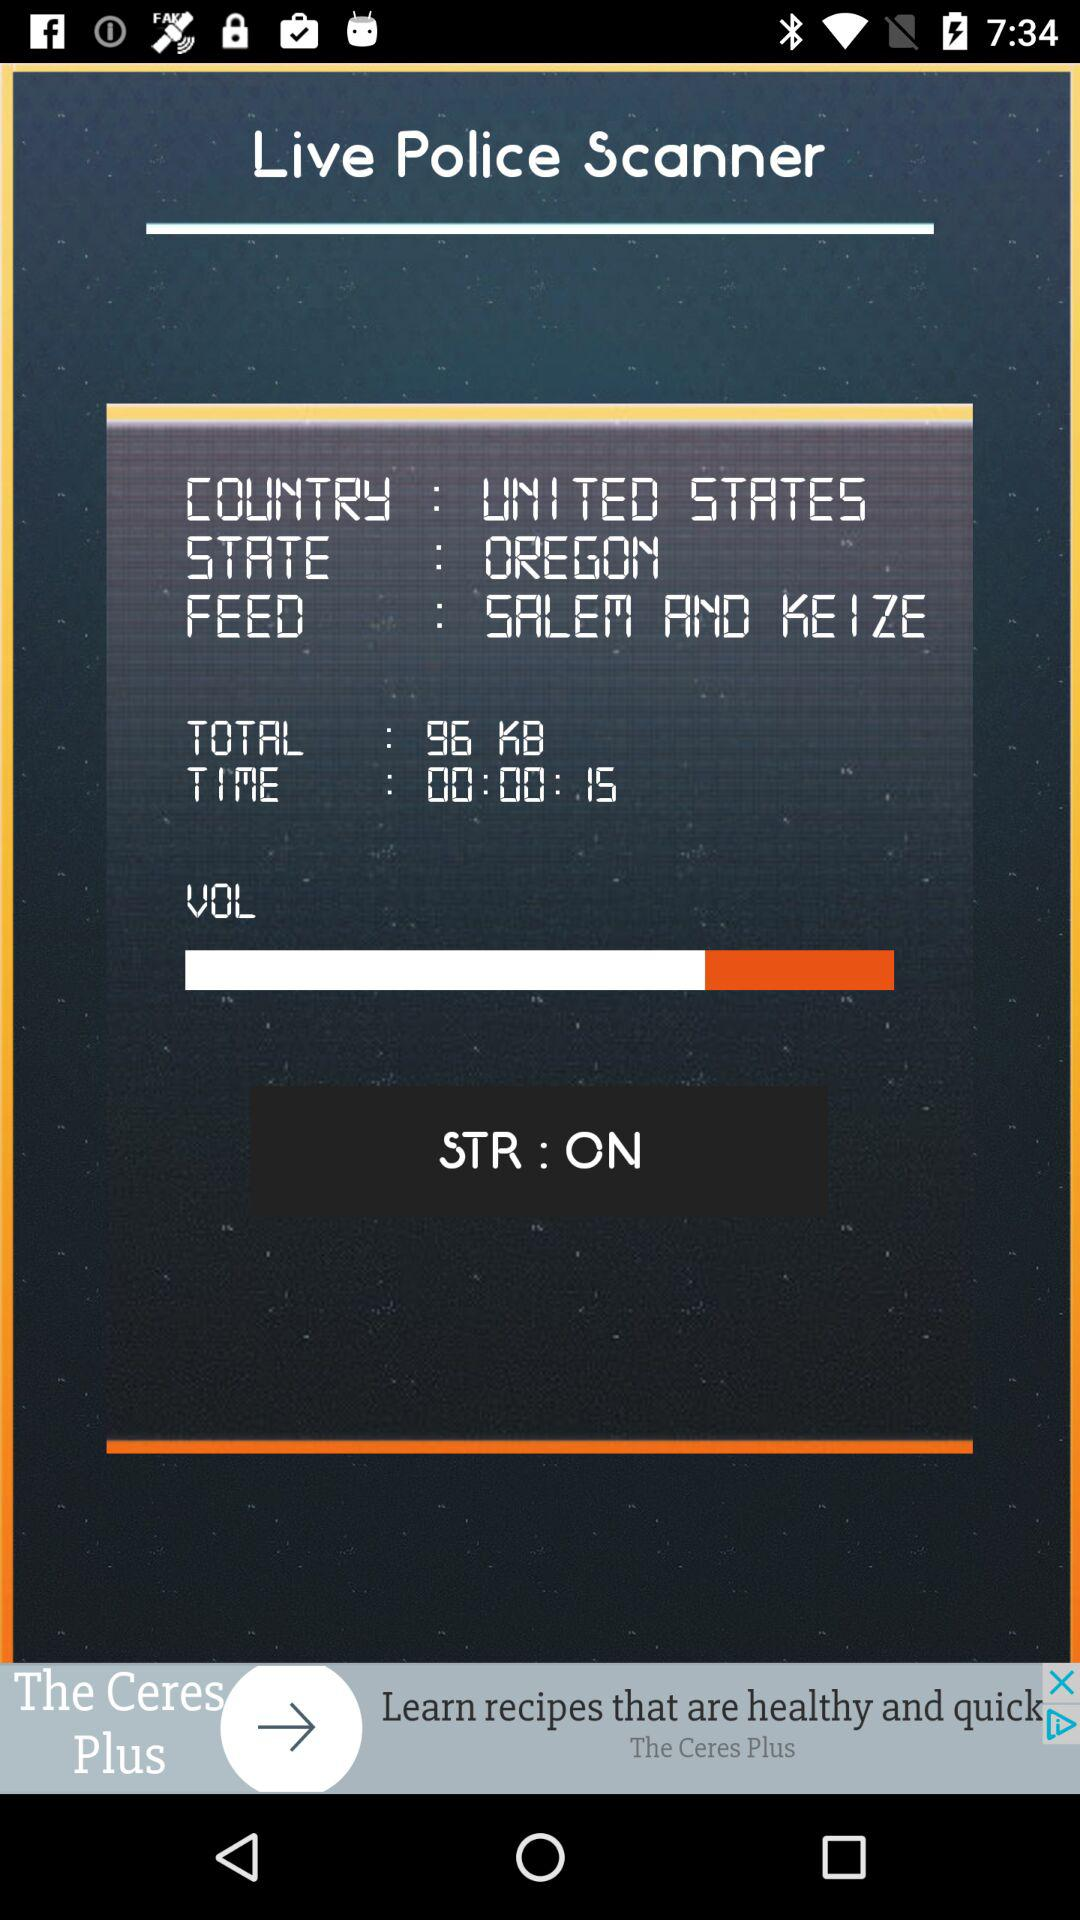What is the status of "STR"? The status is "on". 